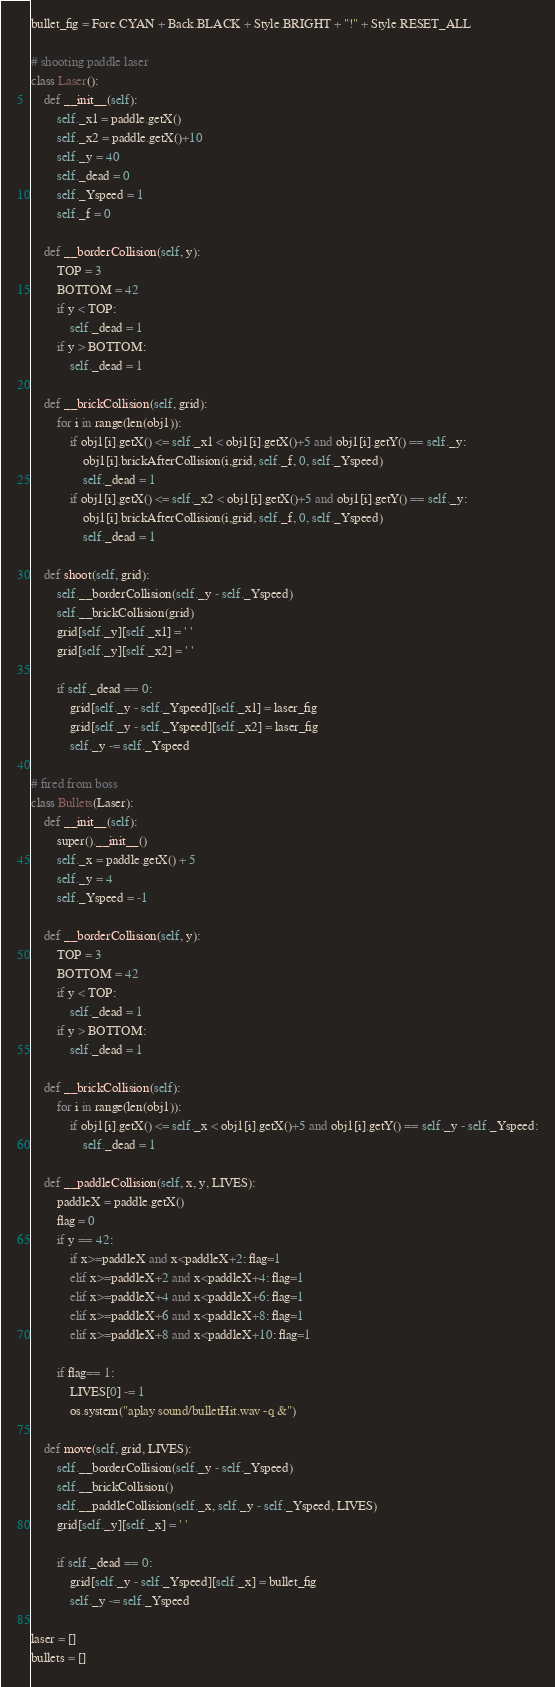<code> <loc_0><loc_0><loc_500><loc_500><_Python_>bullet_fig = Fore.CYAN + Back.BLACK + Style.BRIGHT + "!" + Style.RESET_ALL

# shooting paddle laser
class Laser():
    def __init__(self):
        self._x1 = paddle.getX()
        self._x2 = paddle.getX()+10
        self._y = 40
        self._dead = 0
        self._Yspeed = 1
        self._f = 0
    
    def __borderCollision(self, y):
        TOP = 3
        BOTTOM = 42
        if y < TOP:
            self._dead = 1
        if y > BOTTOM:
            self._dead = 1

    def __brickCollision(self, grid):
        for i in range(len(obj1)):
            if obj1[i].getX() <= self._x1 < obj1[i].getX()+5 and obj1[i].getY() == self._y:
                obj1[i].brickAfterCollision(i,grid, self._f, 0, self._Yspeed)
                self._dead = 1
            if obj1[i].getX() <= self._x2 < obj1[i].getX()+5 and obj1[i].getY() == self._y:
                obj1[i].brickAfterCollision(i,grid, self._f, 0, self._Yspeed)
                self._dead = 1

    def shoot(self, grid):
        self.__borderCollision(self._y - self._Yspeed)
        self.__brickCollision(grid)
        grid[self._y][self._x1] = ' '
        grid[self._y][self._x2] = ' '

        if self._dead == 0:
            grid[self._y - self._Yspeed][self._x1] = laser_fig
            grid[self._y - self._Yspeed][self._x2] = laser_fig
            self._y -= self._Yspeed

# fired from boss
class Bullets(Laser):
    def __init__(self):
        super().__init__()
        self._x = paddle.getX() + 5
        self._y = 4
        self._Yspeed = -1

    def __borderCollision(self, y):
        TOP = 3
        BOTTOM = 42
        if y < TOP:
            self._dead = 1
        if y > BOTTOM:
            self._dead = 1

    def __brickCollision(self):
        for i in range(len(obj1)):
            if obj1[i].getX() <= self._x < obj1[i].getX()+5 and obj1[i].getY() == self._y - self._Yspeed:
                self._dead = 1

    def __paddleCollision(self, x, y, LIVES):
        paddleX = paddle.getX()
        flag = 0
        if y == 42:
            if x>=paddleX and x<paddleX+2: flag=1
            elif x>=paddleX+2 and x<paddleX+4: flag=1
            elif x>=paddleX+4 and x<paddleX+6: flag=1
            elif x>=paddleX+6 and x<paddleX+8: flag=1
            elif x>=paddleX+8 and x<paddleX+10: flag=1

        if flag== 1: 
            LIVES[0] -= 1
            os.system("aplay sound/bulletHit.wav -q &")

    def move(self, grid, LIVES):
        self.__borderCollision(self._y - self._Yspeed)
        self.__brickCollision()
        self.__paddleCollision(self._x, self._y - self._Yspeed, LIVES)
        grid[self._y][self._x] = ' '

        if self._dead == 0:
            grid[self._y - self._Yspeed][self._x] = bullet_fig
            self._y -= self._Yspeed

laser = []
bullets = []</code> 